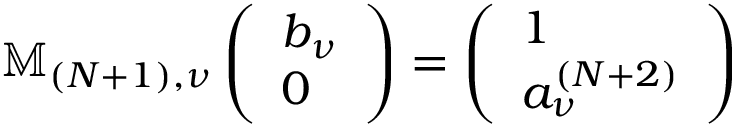<formula> <loc_0><loc_0><loc_500><loc_500>\mathbb { M } _ { ( N + 1 ) , \nu } \left ( \begin{array} { l } { b _ { \nu } } \\ { 0 } \end{array} \right ) = \left ( \begin{array} { l } { 1 } \\ { a _ { \nu } ^ { ( N + 2 ) } } \end{array} \right )</formula> 